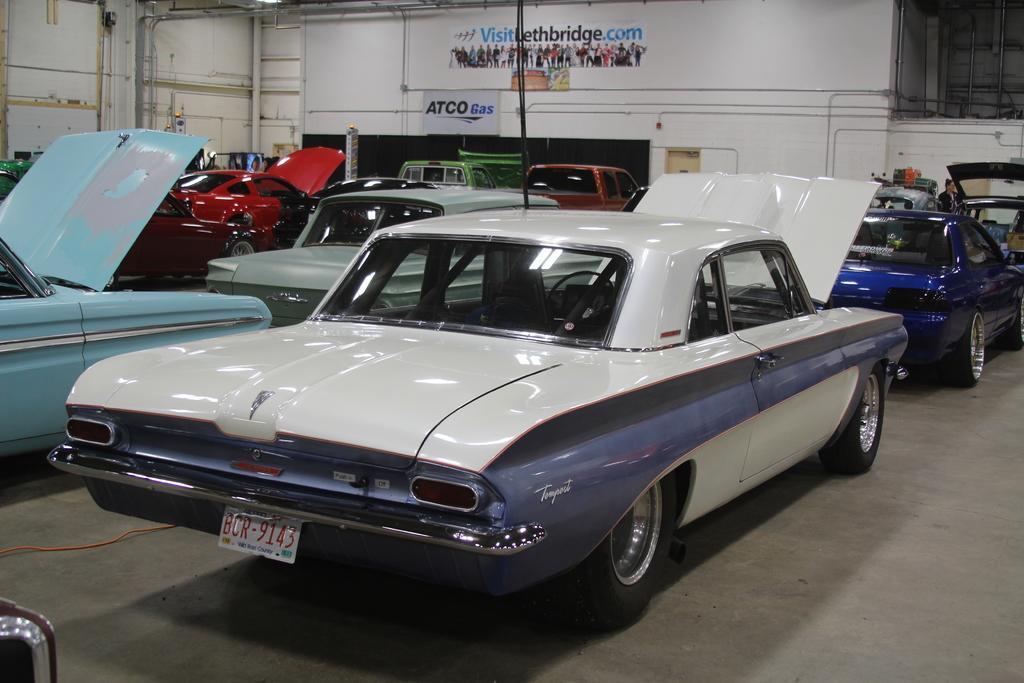How would you summarize this image in a sentence or two? In this picture we can see cars on the ground and in the background we can see pipes, wall, banners. 